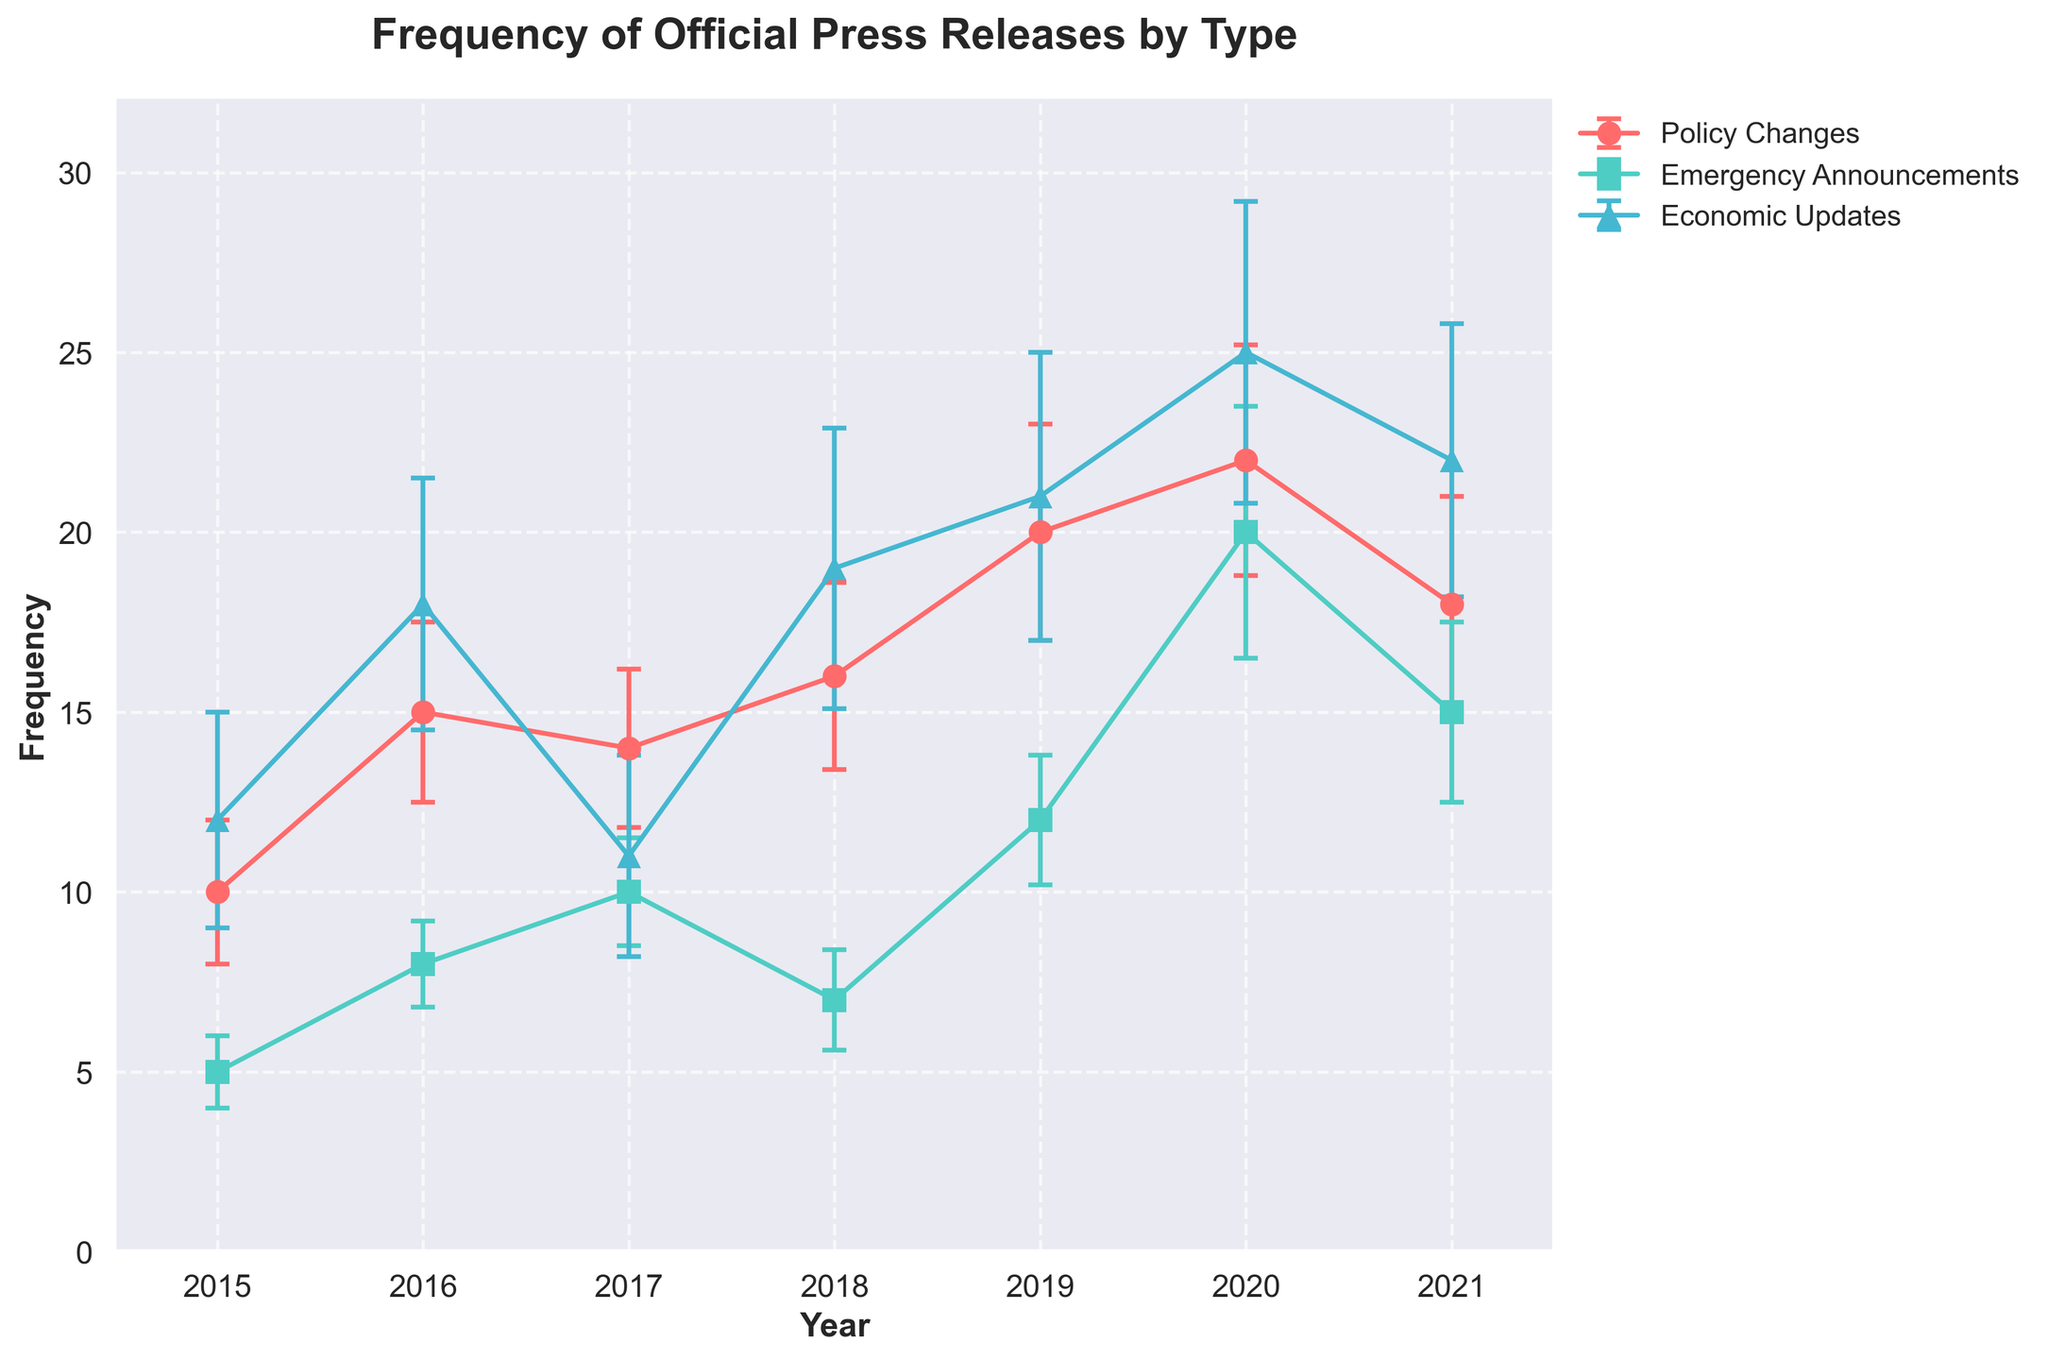What is the title of the figure? The title is the first element that summarizes the figure's purpose. It is usually placed at the top of the graph and provides an overview of what the visual data represents.
Answer: Frequency of Official Press Releases by Type Which type of announcement had the highest mean frequency in 2020? Look at the 2020 data points for each type of announcement and identify the one with the highest mean frequency.
Answer: Economic Updates What is the range of years represented in the figure? Examine the x-axis of the plot, which lists the years, and determine the span from the first to the last year shown.
Answer: 2015 to 2021 How did the frequency of Emergency Announcements change from 2015 to 2020? Identify the data points for Emergency Announcements and subtract the 2015 value from the 2020 value.
Answer: Increased by 15 Which type of announcement had a consistent increase in frequency from 2015 to 2019? Review the lines for each type of announcement and find the one with a consistent upward trend from 2015 to 2019.
Answer: Policy Changes What is the average frequency of Economic Updates over the entire period? Sum the mean frequencies of Economic Updates for each year and divide by the number of years. (12 + 18 + 11 + 19 + 21 + 25 + 22) / 7 = 128 / 7 = 18.29
Answer: 18.29 In which year was the standard deviation of Policy Changes the highest? Compare the standard deviations of Policy Changes across all years and identify the highest value.
Answer: 2019 Are there any years where the frequency of Emergency Announcements decreased compared to the previous year? Compare the consecutive years' frequency values for Emergency Announcements and note any decreases.
Answer: Yes, 2018 (from 2017) Which type of announcement shows the most variability in frequency over the period analyzed? Assess the overall spread of standard deviations for each type of announcement and identify the one with the largest range.
Answer: Economic Updates 